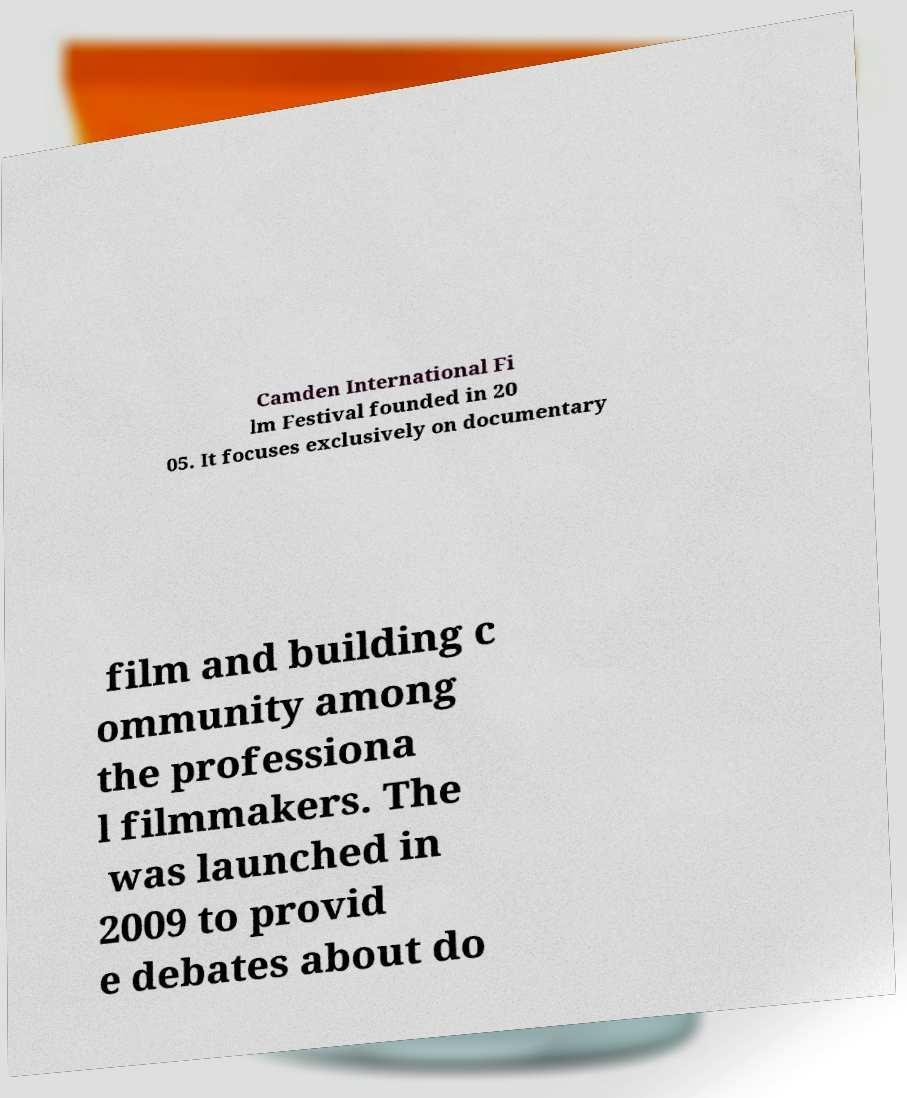For documentation purposes, I need the text within this image transcribed. Could you provide that? Camden International Fi lm Festival founded in 20 05. It focuses exclusively on documentary film and building c ommunity among the professiona l filmmakers. The was launched in 2009 to provid e debates about do 